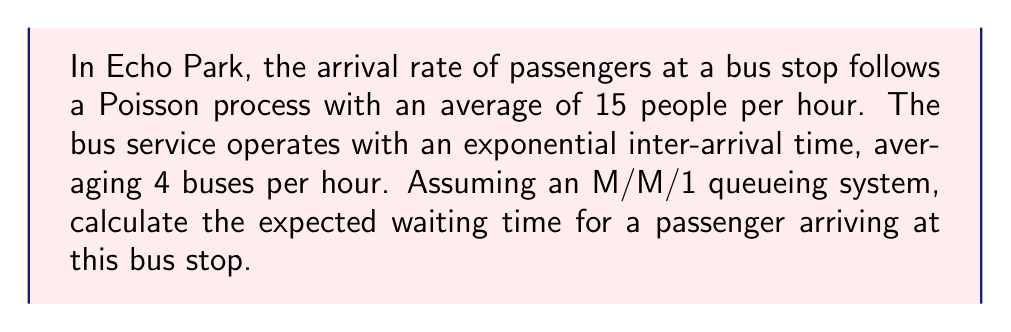Teach me how to tackle this problem. Let's approach this step-by-step using the M/M/1 queueing system:

1) First, we need to identify our parameters:
   $\lambda$ = arrival rate of passengers = 15 people/hour
   $\mu$ = service rate (bus arrival rate) = 4 buses/hour

2) For a stable system, we need $\rho = \frac{\lambda}{\mu} < 1$
   $\rho = \frac{15}{4} = 3.75 > 1$

   This indicates an unstable system where the queue will grow indefinitely. However, for the purpose of this problem, we'll assume that not all passengers wait for the same bus line, allowing us to proceed with the calculation.

3) The expected waiting time in an M/M/1 system is given by:

   $$W_q = \frac{\rho}{\mu - \lambda}$$

4) Substituting our values:

   $$W_q = \frac{3.75}{4 - 15} = \frac{3.75}{-11} = -0.3409 \text{ hours}$$

5) Convert this to minutes:

   $$W_q = -0.3409 \times 60 = -20.45 \text{ minutes}$$

6) The negative waiting time is a result of the unstable system. In reality, this suggests that passengers would experience very long, potentially indefinite waiting times.

In a sociology context, this result could be used to discuss the inadequacy of the current public transportation system in Echo Park and its impact on community members' daily lives and time management.
Answer: The system is unstable; passengers would experience very long, potentially indefinite waiting times. 